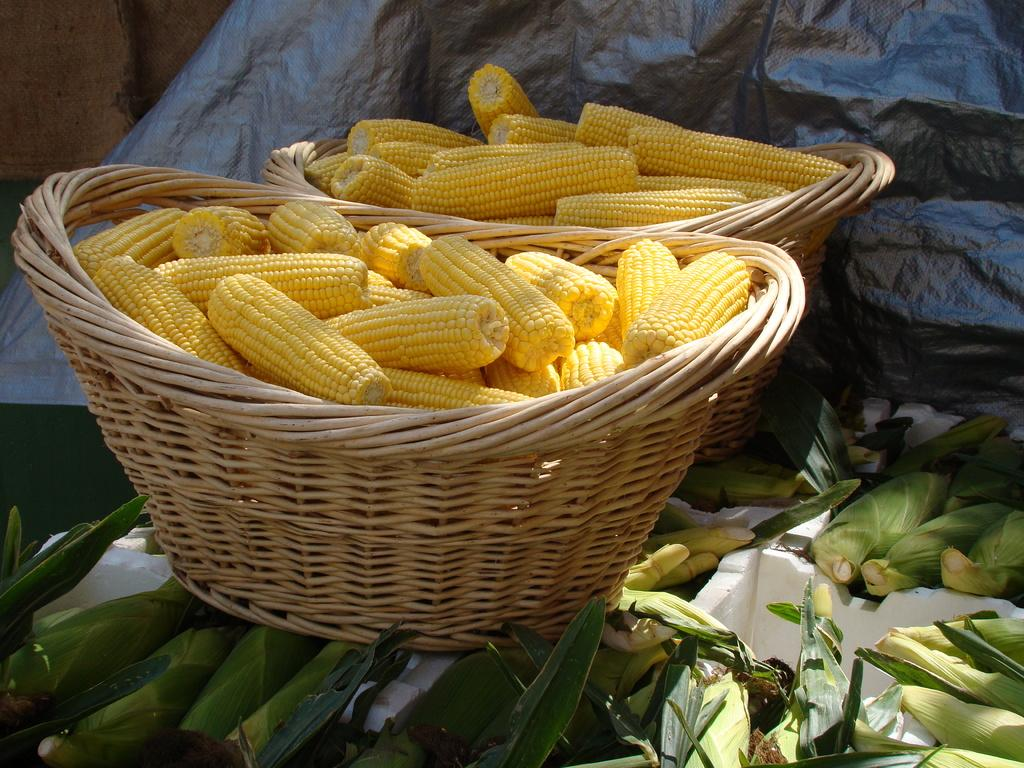How many wooden baskets are in the image? There are two wooden baskets in the image. What are the baskets filled with? The baskets are filled with sweet corns. Are there any other corns visible in the image? Yes, there are additional corns around the baskets. What is located behind the baskets? There is a cover behind the baskets. What type of berry is being used to decorate the baskets in the image? There are no berries present in the image; the baskets are filled with sweet corns. How many eggs are visible in the image? There are no eggs visible in the image. 